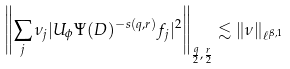<formula> <loc_0><loc_0><loc_500><loc_500>\left \| \sum _ { j } \nu _ { j } | U _ { \phi } \Psi ( D ) ^ { - s ( q , r ) } f _ { j } | ^ { 2 } \right \| _ { \frac { q } { 2 } , \frac { r } { 2 } } \lesssim \| \nu \| _ { \ell ^ { \beta , 1 } }</formula> 